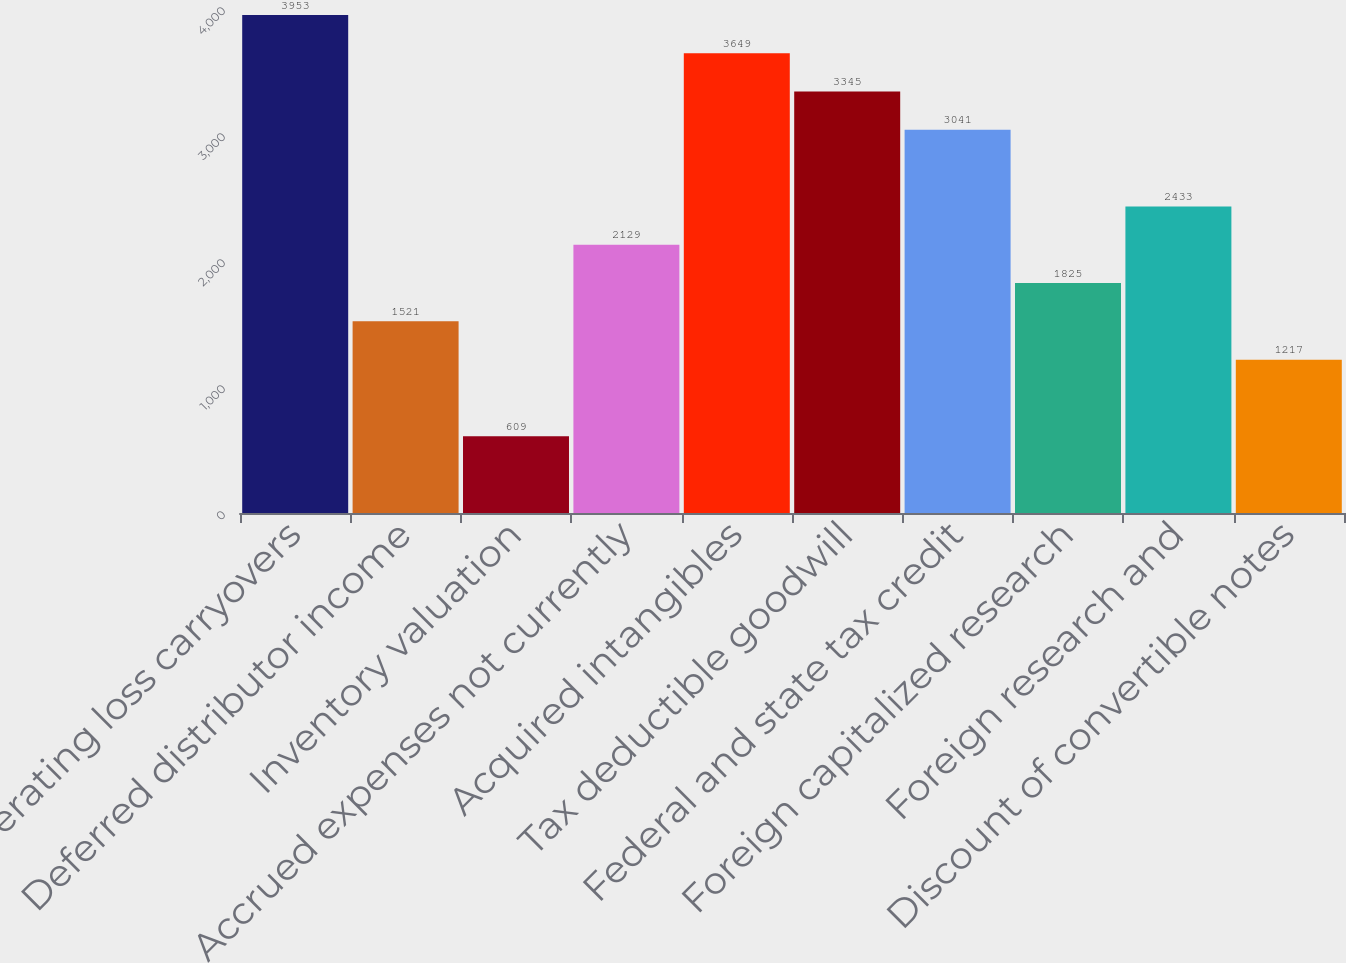Convert chart. <chart><loc_0><loc_0><loc_500><loc_500><bar_chart><fcel>Net operating loss carryovers<fcel>Deferred distributor income<fcel>Inventory valuation<fcel>Accrued expenses not currently<fcel>Acquired intangibles<fcel>Tax deductible goodwill<fcel>Federal and state tax credit<fcel>Foreign capitalized research<fcel>Foreign research and<fcel>Discount of convertible notes<nl><fcel>3953<fcel>1521<fcel>609<fcel>2129<fcel>3649<fcel>3345<fcel>3041<fcel>1825<fcel>2433<fcel>1217<nl></chart> 